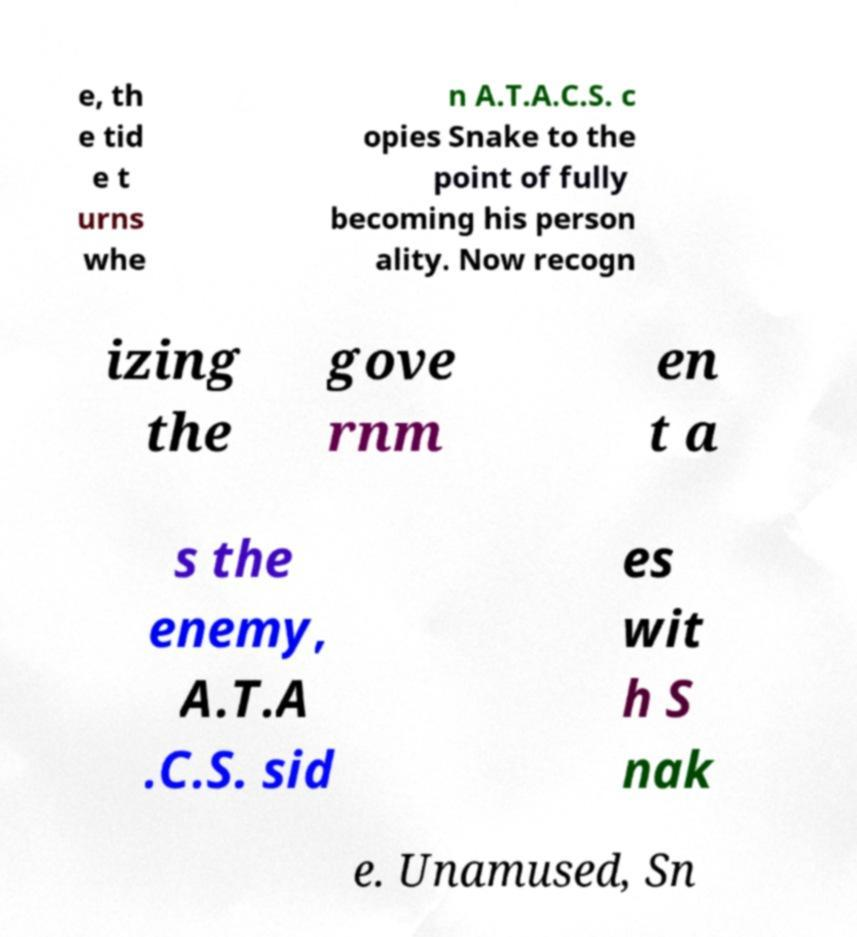Please read and relay the text visible in this image. What does it say? e, th e tid e t urns whe n A.T.A.C.S. c opies Snake to the point of fully becoming his person ality. Now recogn izing the gove rnm en t a s the enemy, A.T.A .C.S. sid es wit h S nak e. Unamused, Sn 